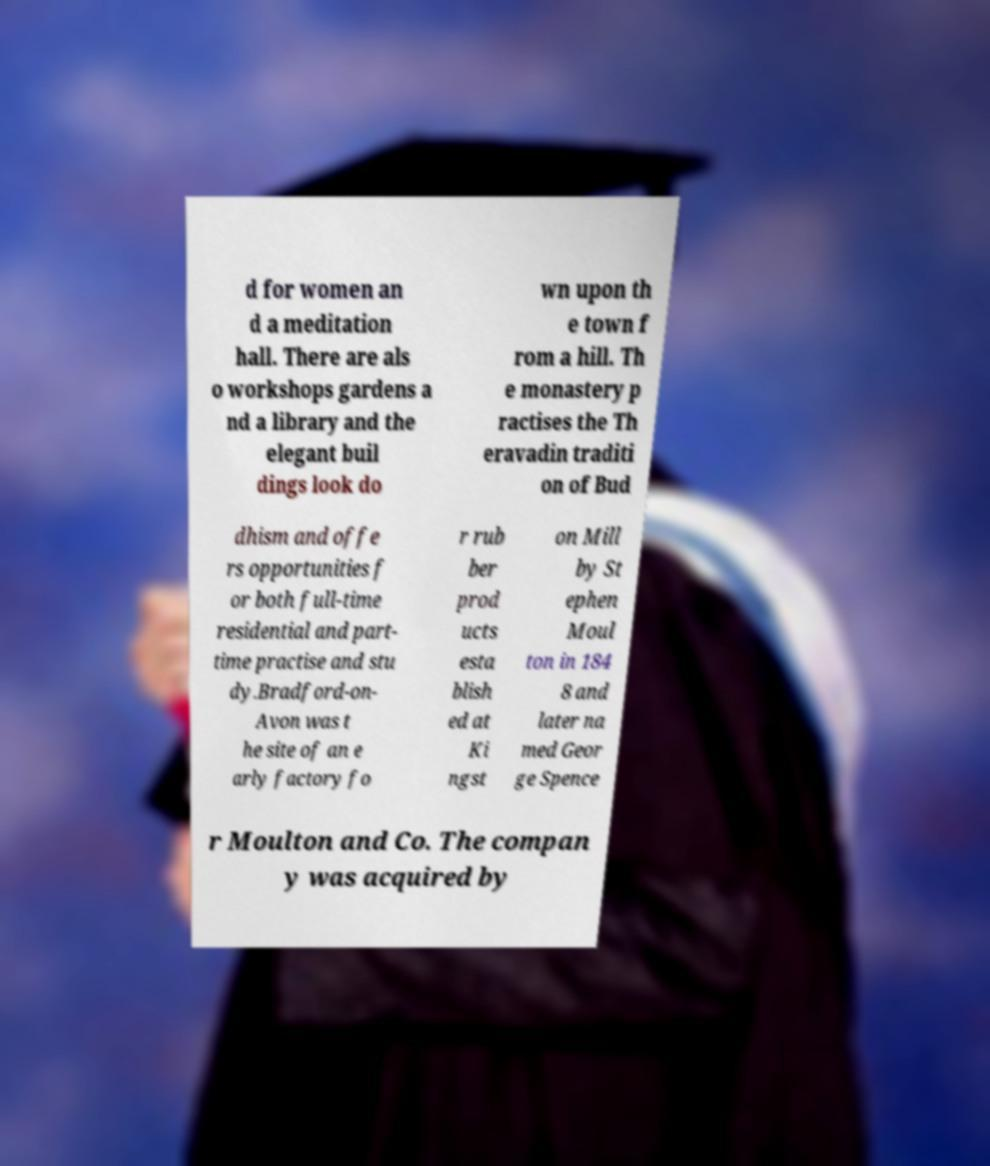Can you accurately transcribe the text from the provided image for me? d for women an d a meditation hall. There are als o workshops gardens a nd a library and the elegant buil dings look do wn upon th e town f rom a hill. Th e monastery p ractises the Th eravadin traditi on of Bud dhism and offe rs opportunities f or both full-time residential and part- time practise and stu dy.Bradford-on- Avon was t he site of an e arly factory fo r rub ber prod ucts esta blish ed at Ki ngst on Mill by St ephen Moul ton in 184 8 and later na med Geor ge Spence r Moulton and Co. The compan y was acquired by 